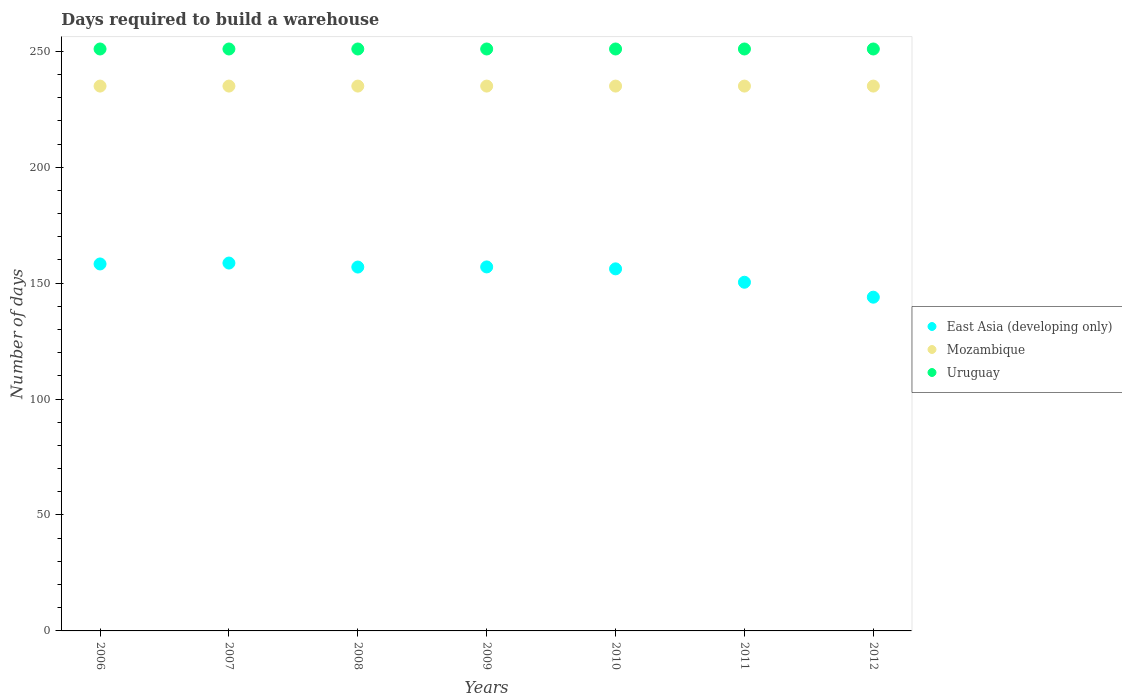How many different coloured dotlines are there?
Give a very brief answer. 3. What is the days required to build a warehouse in in Uruguay in 2010?
Your response must be concise. 251. Across all years, what is the maximum days required to build a warehouse in in Uruguay?
Offer a very short reply. 251. Across all years, what is the minimum days required to build a warehouse in in Uruguay?
Offer a very short reply. 251. What is the total days required to build a warehouse in in Mozambique in the graph?
Provide a succinct answer. 1645. What is the difference between the days required to build a warehouse in in Mozambique in 2010 and that in 2012?
Make the answer very short. 0. What is the difference between the days required to build a warehouse in in East Asia (developing only) in 2007 and the days required to build a warehouse in in Mozambique in 2008?
Keep it short and to the point. -76.33. What is the average days required to build a warehouse in in East Asia (developing only) per year?
Make the answer very short. 154.48. In the year 2009, what is the difference between the days required to build a warehouse in in Uruguay and days required to build a warehouse in in East Asia (developing only)?
Provide a succinct answer. 94. What is the ratio of the days required to build a warehouse in in Mozambique in 2006 to that in 2010?
Offer a terse response. 1. What is the difference between the highest and the second highest days required to build a warehouse in in Uruguay?
Provide a short and direct response. 0. Is it the case that in every year, the sum of the days required to build a warehouse in in Mozambique and days required to build a warehouse in in Uruguay  is greater than the days required to build a warehouse in in East Asia (developing only)?
Keep it short and to the point. Yes. Is the days required to build a warehouse in in Mozambique strictly less than the days required to build a warehouse in in East Asia (developing only) over the years?
Ensure brevity in your answer.  No. Does the graph contain any zero values?
Make the answer very short. No. Where does the legend appear in the graph?
Offer a terse response. Center right. How many legend labels are there?
Provide a succinct answer. 3. What is the title of the graph?
Provide a short and direct response. Days required to build a warehouse. Does "Botswana" appear as one of the legend labels in the graph?
Ensure brevity in your answer.  No. What is the label or title of the X-axis?
Keep it short and to the point. Years. What is the label or title of the Y-axis?
Your response must be concise. Number of days. What is the Number of days in East Asia (developing only) in 2006?
Offer a very short reply. 158.28. What is the Number of days in Mozambique in 2006?
Provide a short and direct response. 235. What is the Number of days of Uruguay in 2006?
Offer a terse response. 251. What is the Number of days in East Asia (developing only) in 2007?
Make the answer very short. 158.67. What is the Number of days of Mozambique in 2007?
Your answer should be compact. 235. What is the Number of days of Uruguay in 2007?
Your answer should be compact. 251. What is the Number of days in East Asia (developing only) in 2008?
Offer a terse response. 156.94. What is the Number of days in Mozambique in 2008?
Your answer should be very brief. 235. What is the Number of days in Uruguay in 2008?
Offer a terse response. 251. What is the Number of days of East Asia (developing only) in 2009?
Keep it short and to the point. 157. What is the Number of days in Mozambique in 2009?
Provide a short and direct response. 235. What is the Number of days of Uruguay in 2009?
Offer a terse response. 251. What is the Number of days in East Asia (developing only) in 2010?
Keep it short and to the point. 156.17. What is the Number of days of Mozambique in 2010?
Provide a succinct answer. 235. What is the Number of days of Uruguay in 2010?
Ensure brevity in your answer.  251. What is the Number of days in East Asia (developing only) in 2011?
Your answer should be very brief. 150.39. What is the Number of days of Mozambique in 2011?
Ensure brevity in your answer.  235. What is the Number of days in Uruguay in 2011?
Keep it short and to the point. 251. What is the Number of days in East Asia (developing only) in 2012?
Give a very brief answer. 143.95. What is the Number of days of Mozambique in 2012?
Your response must be concise. 235. What is the Number of days in Uruguay in 2012?
Ensure brevity in your answer.  251. Across all years, what is the maximum Number of days of East Asia (developing only)?
Your answer should be compact. 158.67. Across all years, what is the maximum Number of days in Mozambique?
Ensure brevity in your answer.  235. Across all years, what is the maximum Number of days in Uruguay?
Ensure brevity in your answer.  251. Across all years, what is the minimum Number of days of East Asia (developing only)?
Give a very brief answer. 143.95. Across all years, what is the minimum Number of days of Mozambique?
Your response must be concise. 235. Across all years, what is the minimum Number of days of Uruguay?
Your answer should be very brief. 251. What is the total Number of days in East Asia (developing only) in the graph?
Keep it short and to the point. 1081.39. What is the total Number of days in Mozambique in the graph?
Ensure brevity in your answer.  1645. What is the total Number of days of Uruguay in the graph?
Provide a succinct answer. 1757. What is the difference between the Number of days of East Asia (developing only) in 2006 and that in 2007?
Provide a short and direct response. -0.39. What is the difference between the Number of days of Mozambique in 2006 and that in 2007?
Provide a short and direct response. 0. What is the difference between the Number of days of Uruguay in 2006 and that in 2007?
Your answer should be compact. 0. What is the difference between the Number of days of East Asia (developing only) in 2006 and that in 2008?
Give a very brief answer. 1.33. What is the difference between the Number of days in East Asia (developing only) in 2006 and that in 2009?
Your answer should be very brief. 1.28. What is the difference between the Number of days in Mozambique in 2006 and that in 2009?
Offer a terse response. 0. What is the difference between the Number of days of Uruguay in 2006 and that in 2009?
Ensure brevity in your answer.  0. What is the difference between the Number of days in East Asia (developing only) in 2006 and that in 2010?
Offer a very short reply. 2.11. What is the difference between the Number of days in Uruguay in 2006 and that in 2010?
Your answer should be compact. 0. What is the difference between the Number of days in East Asia (developing only) in 2006 and that in 2011?
Give a very brief answer. 7.89. What is the difference between the Number of days of Mozambique in 2006 and that in 2011?
Give a very brief answer. 0. What is the difference between the Number of days of Uruguay in 2006 and that in 2011?
Offer a terse response. 0. What is the difference between the Number of days of East Asia (developing only) in 2006 and that in 2012?
Provide a short and direct response. 14.33. What is the difference between the Number of days of East Asia (developing only) in 2007 and that in 2008?
Offer a terse response. 1.72. What is the difference between the Number of days of Mozambique in 2007 and that in 2009?
Your response must be concise. 0. What is the difference between the Number of days of East Asia (developing only) in 2007 and that in 2010?
Provide a succinct answer. 2.5. What is the difference between the Number of days in Mozambique in 2007 and that in 2010?
Your response must be concise. 0. What is the difference between the Number of days in East Asia (developing only) in 2007 and that in 2011?
Ensure brevity in your answer.  8.28. What is the difference between the Number of days of Uruguay in 2007 and that in 2011?
Your answer should be compact. 0. What is the difference between the Number of days in East Asia (developing only) in 2007 and that in 2012?
Ensure brevity in your answer.  14.72. What is the difference between the Number of days in Mozambique in 2007 and that in 2012?
Your answer should be very brief. 0. What is the difference between the Number of days of Uruguay in 2007 and that in 2012?
Offer a terse response. 0. What is the difference between the Number of days in East Asia (developing only) in 2008 and that in 2009?
Provide a short and direct response. -0.06. What is the difference between the Number of days in East Asia (developing only) in 2008 and that in 2010?
Give a very brief answer. 0.78. What is the difference between the Number of days in East Asia (developing only) in 2008 and that in 2011?
Your answer should be very brief. 6.56. What is the difference between the Number of days in East Asia (developing only) in 2008 and that in 2012?
Keep it short and to the point. 13. What is the difference between the Number of days of Mozambique in 2008 and that in 2012?
Ensure brevity in your answer.  0. What is the difference between the Number of days in Mozambique in 2009 and that in 2010?
Provide a short and direct response. 0. What is the difference between the Number of days of East Asia (developing only) in 2009 and that in 2011?
Your response must be concise. 6.61. What is the difference between the Number of days of Mozambique in 2009 and that in 2011?
Your response must be concise. 0. What is the difference between the Number of days of East Asia (developing only) in 2009 and that in 2012?
Offer a terse response. 13.05. What is the difference between the Number of days in Mozambique in 2009 and that in 2012?
Your response must be concise. 0. What is the difference between the Number of days of East Asia (developing only) in 2010 and that in 2011?
Keep it short and to the point. 5.78. What is the difference between the Number of days of Uruguay in 2010 and that in 2011?
Provide a succinct answer. 0. What is the difference between the Number of days of East Asia (developing only) in 2010 and that in 2012?
Your response must be concise. 12.22. What is the difference between the Number of days of East Asia (developing only) in 2011 and that in 2012?
Provide a succinct answer. 6.44. What is the difference between the Number of days of East Asia (developing only) in 2006 and the Number of days of Mozambique in 2007?
Give a very brief answer. -76.72. What is the difference between the Number of days of East Asia (developing only) in 2006 and the Number of days of Uruguay in 2007?
Your answer should be compact. -92.72. What is the difference between the Number of days of Mozambique in 2006 and the Number of days of Uruguay in 2007?
Make the answer very short. -16. What is the difference between the Number of days of East Asia (developing only) in 2006 and the Number of days of Mozambique in 2008?
Make the answer very short. -76.72. What is the difference between the Number of days in East Asia (developing only) in 2006 and the Number of days in Uruguay in 2008?
Give a very brief answer. -92.72. What is the difference between the Number of days in Mozambique in 2006 and the Number of days in Uruguay in 2008?
Ensure brevity in your answer.  -16. What is the difference between the Number of days of East Asia (developing only) in 2006 and the Number of days of Mozambique in 2009?
Offer a terse response. -76.72. What is the difference between the Number of days of East Asia (developing only) in 2006 and the Number of days of Uruguay in 2009?
Offer a terse response. -92.72. What is the difference between the Number of days of East Asia (developing only) in 2006 and the Number of days of Mozambique in 2010?
Keep it short and to the point. -76.72. What is the difference between the Number of days in East Asia (developing only) in 2006 and the Number of days in Uruguay in 2010?
Ensure brevity in your answer.  -92.72. What is the difference between the Number of days in East Asia (developing only) in 2006 and the Number of days in Mozambique in 2011?
Provide a short and direct response. -76.72. What is the difference between the Number of days in East Asia (developing only) in 2006 and the Number of days in Uruguay in 2011?
Offer a terse response. -92.72. What is the difference between the Number of days in Mozambique in 2006 and the Number of days in Uruguay in 2011?
Keep it short and to the point. -16. What is the difference between the Number of days in East Asia (developing only) in 2006 and the Number of days in Mozambique in 2012?
Offer a terse response. -76.72. What is the difference between the Number of days of East Asia (developing only) in 2006 and the Number of days of Uruguay in 2012?
Offer a very short reply. -92.72. What is the difference between the Number of days of East Asia (developing only) in 2007 and the Number of days of Mozambique in 2008?
Give a very brief answer. -76.33. What is the difference between the Number of days in East Asia (developing only) in 2007 and the Number of days in Uruguay in 2008?
Your answer should be very brief. -92.33. What is the difference between the Number of days of East Asia (developing only) in 2007 and the Number of days of Mozambique in 2009?
Your answer should be compact. -76.33. What is the difference between the Number of days in East Asia (developing only) in 2007 and the Number of days in Uruguay in 2009?
Provide a succinct answer. -92.33. What is the difference between the Number of days in Mozambique in 2007 and the Number of days in Uruguay in 2009?
Give a very brief answer. -16. What is the difference between the Number of days in East Asia (developing only) in 2007 and the Number of days in Mozambique in 2010?
Ensure brevity in your answer.  -76.33. What is the difference between the Number of days of East Asia (developing only) in 2007 and the Number of days of Uruguay in 2010?
Ensure brevity in your answer.  -92.33. What is the difference between the Number of days of Mozambique in 2007 and the Number of days of Uruguay in 2010?
Make the answer very short. -16. What is the difference between the Number of days of East Asia (developing only) in 2007 and the Number of days of Mozambique in 2011?
Your response must be concise. -76.33. What is the difference between the Number of days of East Asia (developing only) in 2007 and the Number of days of Uruguay in 2011?
Make the answer very short. -92.33. What is the difference between the Number of days of Mozambique in 2007 and the Number of days of Uruguay in 2011?
Your answer should be very brief. -16. What is the difference between the Number of days in East Asia (developing only) in 2007 and the Number of days in Mozambique in 2012?
Provide a short and direct response. -76.33. What is the difference between the Number of days in East Asia (developing only) in 2007 and the Number of days in Uruguay in 2012?
Give a very brief answer. -92.33. What is the difference between the Number of days of East Asia (developing only) in 2008 and the Number of days of Mozambique in 2009?
Make the answer very short. -78.06. What is the difference between the Number of days in East Asia (developing only) in 2008 and the Number of days in Uruguay in 2009?
Provide a short and direct response. -94.06. What is the difference between the Number of days of Mozambique in 2008 and the Number of days of Uruguay in 2009?
Your response must be concise. -16. What is the difference between the Number of days in East Asia (developing only) in 2008 and the Number of days in Mozambique in 2010?
Your answer should be compact. -78.06. What is the difference between the Number of days in East Asia (developing only) in 2008 and the Number of days in Uruguay in 2010?
Keep it short and to the point. -94.06. What is the difference between the Number of days in East Asia (developing only) in 2008 and the Number of days in Mozambique in 2011?
Your response must be concise. -78.06. What is the difference between the Number of days in East Asia (developing only) in 2008 and the Number of days in Uruguay in 2011?
Ensure brevity in your answer.  -94.06. What is the difference between the Number of days of East Asia (developing only) in 2008 and the Number of days of Mozambique in 2012?
Your response must be concise. -78.06. What is the difference between the Number of days in East Asia (developing only) in 2008 and the Number of days in Uruguay in 2012?
Provide a succinct answer. -94.06. What is the difference between the Number of days in East Asia (developing only) in 2009 and the Number of days in Mozambique in 2010?
Make the answer very short. -78. What is the difference between the Number of days of East Asia (developing only) in 2009 and the Number of days of Uruguay in 2010?
Offer a terse response. -94. What is the difference between the Number of days of Mozambique in 2009 and the Number of days of Uruguay in 2010?
Offer a very short reply. -16. What is the difference between the Number of days in East Asia (developing only) in 2009 and the Number of days in Mozambique in 2011?
Offer a terse response. -78. What is the difference between the Number of days in East Asia (developing only) in 2009 and the Number of days in Uruguay in 2011?
Give a very brief answer. -94. What is the difference between the Number of days in Mozambique in 2009 and the Number of days in Uruguay in 2011?
Your response must be concise. -16. What is the difference between the Number of days of East Asia (developing only) in 2009 and the Number of days of Mozambique in 2012?
Ensure brevity in your answer.  -78. What is the difference between the Number of days of East Asia (developing only) in 2009 and the Number of days of Uruguay in 2012?
Make the answer very short. -94. What is the difference between the Number of days in East Asia (developing only) in 2010 and the Number of days in Mozambique in 2011?
Offer a very short reply. -78.83. What is the difference between the Number of days of East Asia (developing only) in 2010 and the Number of days of Uruguay in 2011?
Provide a succinct answer. -94.83. What is the difference between the Number of days of Mozambique in 2010 and the Number of days of Uruguay in 2011?
Give a very brief answer. -16. What is the difference between the Number of days of East Asia (developing only) in 2010 and the Number of days of Mozambique in 2012?
Your answer should be compact. -78.83. What is the difference between the Number of days in East Asia (developing only) in 2010 and the Number of days in Uruguay in 2012?
Ensure brevity in your answer.  -94.83. What is the difference between the Number of days in Mozambique in 2010 and the Number of days in Uruguay in 2012?
Offer a terse response. -16. What is the difference between the Number of days of East Asia (developing only) in 2011 and the Number of days of Mozambique in 2012?
Ensure brevity in your answer.  -84.61. What is the difference between the Number of days of East Asia (developing only) in 2011 and the Number of days of Uruguay in 2012?
Your answer should be very brief. -100.61. What is the average Number of days in East Asia (developing only) per year?
Your answer should be compact. 154.48. What is the average Number of days in Mozambique per year?
Make the answer very short. 235. What is the average Number of days of Uruguay per year?
Make the answer very short. 251. In the year 2006, what is the difference between the Number of days of East Asia (developing only) and Number of days of Mozambique?
Make the answer very short. -76.72. In the year 2006, what is the difference between the Number of days of East Asia (developing only) and Number of days of Uruguay?
Make the answer very short. -92.72. In the year 2006, what is the difference between the Number of days in Mozambique and Number of days in Uruguay?
Your response must be concise. -16. In the year 2007, what is the difference between the Number of days in East Asia (developing only) and Number of days in Mozambique?
Make the answer very short. -76.33. In the year 2007, what is the difference between the Number of days of East Asia (developing only) and Number of days of Uruguay?
Offer a very short reply. -92.33. In the year 2008, what is the difference between the Number of days of East Asia (developing only) and Number of days of Mozambique?
Offer a terse response. -78.06. In the year 2008, what is the difference between the Number of days of East Asia (developing only) and Number of days of Uruguay?
Your response must be concise. -94.06. In the year 2009, what is the difference between the Number of days in East Asia (developing only) and Number of days in Mozambique?
Ensure brevity in your answer.  -78. In the year 2009, what is the difference between the Number of days of East Asia (developing only) and Number of days of Uruguay?
Your answer should be very brief. -94. In the year 2010, what is the difference between the Number of days of East Asia (developing only) and Number of days of Mozambique?
Your answer should be very brief. -78.83. In the year 2010, what is the difference between the Number of days in East Asia (developing only) and Number of days in Uruguay?
Offer a very short reply. -94.83. In the year 2010, what is the difference between the Number of days of Mozambique and Number of days of Uruguay?
Your answer should be compact. -16. In the year 2011, what is the difference between the Number of days of East Asia (developing only) and Number of days of Mozambique?
Offer a very short reply. -84.61. In the year 2011, what is the difference between the Number of days of East Asia (developing only) and Number of days of Uruguay?
Provide a succinct answer. -100.61. In the year 2011, what is the difference between the Number of days in Mozambique and Number of days in Uruguay?
Ensure brevity in your answer.  -16. In the year 2012, what is the difference between the Number of days in East Asia (developing only) and Number of days in Mozambique?
Provide a succinct answer. -91.05. In the year 2012, what is the difference between the Number of days of East Asia (developing only) and Number of days of Uruguay?
Make the answer very short. -107.05. What is the ratio of the Number of days of Mozambique in 2006 to that in 2007?
Your response must be concise. 1. What is the ratio of the Number of days in East Asia (developing only) in 2006 to that in 2008?
Your answer should be very brief. 1.01. What is the ratio of the Number of days of East Asia (developing only) in 2006 to that in 2010?
Give a very brief answer. 1.01. What is the ratio of the Number of days of Mozambique in 2006 to that in 2010?
Your response must be concise. 1. What is the ratio of the Number of days in Uruguay in 2006 to that in 2010?
Provide a short and direct response. 1. What is the ratio of the Number of days in East Asia (developing only) in 2006 to that in 2011?
Your answer should be compact. 1.05. What is the ratio of the Number of days in Mozambique in 2006 to that in 2011?
Offer a very short reply. 1. What is the ratio of the Number of days of Uruguay in 2006 to that in 2011?
Keep it short and to the point. 1. What is the ratio of the Number of days of East Asia (developing only) in 2006 to that in 2012?
Offer a very short reply. 1.1. What is the ratio of the Number of days in Mozambique in 2006 to that in 2012?
Keep it short and to the point. 1. What is the ratio of the Number of days of Uruguay in 2006 to that in 2012?
Provide a succinct answer. 1. What is the ratio of the Number of days of Mozambique in 2007 to that in 2008?
Your response must be concise. 1. What is the ratio of the Number of days of Uruguay in 2007 to that in 2008?
Make the answer very short. 1. What is the ratio of the Number of days in East Asia (developing only) in 2007 to that in 2009?
Your response must be concise. 1.01. What is the ratio of the Number of days of Mozambique in 2007 to that in 2009?
Provide a succinct answer. 1. What is the ratio of the Number of days in Mozambique in 2007 to that in 2010?
Give a very brief answer. 1. What is the ratio of the Number of days in Uruguay in 2007 to that in 2010?
Provide a succinct answer. 1. What is the ratio of the Number of days in East Asia (developing only) in 2007 to that in 2011?
Ensure brevity in your answer.  1.05. What is the ratio of the Number of days in East Asia (developing only) in 2007 to that in 2012?
Give a very brief answer. 1.1. What is the ratio of the Number of days in Mozambique in 2007 to that in 2012?
Provide a succinct answer. 1. What is the ratio of the Number of days of East Asia (developing only) in 2008 to that in 2009?
Offer a very short reply. 1. What is the ratio of the Number of days of Mozambique in 2008 to that in 2009?
Your response must be concise. 1. What is the ratio of the Number of days in Mozambique in 2008 to that in 2010?
Give a very brief answer. 1. What is the ratio of the Number of days in Uruguay in 2008 to that in 2010?
Offer a very short reply. 1. What is the ratio of the Number of days in East Asia (developing only) in 2008 to that in 2011?
Provide a succinct answer. 1.04. What is the ratio of the Number of days in East Asia (developing only) in 2008 to that in 2012?
Ensure brevity in your answer.  1.09. What is the ratio of the Number of days in Mozambique in 2008 to that in 2012?
Your response must be concise. 1. What is the ratio of the Number of days of Mozambique in 2009 to that in 2010?
Offer a very short reply. 1. What is the ratio of the Number of days in Uruguay in 2009 to that in 2010?
Ensure brevity in your answer.  1. What is the ratio of the Number of days in East Asia (developing only) in 2009 to that in 2011?
Make the answer very short. 1.04. What is the ratio of the Number of days of Mozambique in 2009 to that in 2011?
Provide a succinct answer. 1. What is the ratio of the Number of days of East Asia (developing only) in 2009 to that in 2012?
Ensure brevity in your answer.  1.09. What is the ratio of the Number of days in Mozambique in 2009 to that in 2012?
Your response must be concise. 1. What is the ratio of the Number of days in Uruguay in 2009 to that in 2012?
Your answer should be compact. 1. What is the ratio of the Number of days in East Asia (developing only) in 2010 to that in 2011?
Your answer should be very brief. 1.04. What is the ratio of the Number of days of Uruguay in 2010 to that in 2011?
Your answer should be compact. 1. What is the ratio of the Number of days of East Asia (developing only) in 2010 to that in 2012?
Keep it short and to the point. 1.08. What is the ratio of the Number of days of Uruguay in 2010 to that in 2012?
Provide a succinct answer. 1. What is the ratio of the Number of days in East Asia (developing only) in 2011 to that in 2012?
Give a very brief answer. 1.04. What is the ratio of the Number of days in Mozambique in 2011 to that in 2012?
Offer a terse response. 1. What is the ratio of the Number of days in Uruguay in 2011 to that in 2012?
Offer a very short reply. 1. What is the difference between the highest and the second highest Number of days of East Asia (developing only)?
Offer a terse response. 0.39. What is the difference between the highest and the lowest Number of days in East Asia (developing only)?
Your answer should be compact. 14.72. What is the difference between the highest and the lowest Number of days in Uruguay?
Your answer should be very brief. 0. 